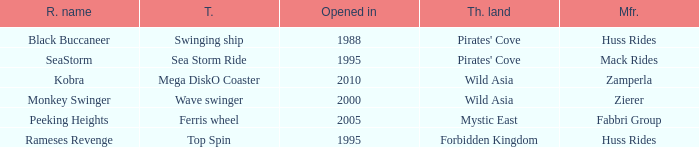What ride was manufactured by Zierer? Monkey Swinger. 